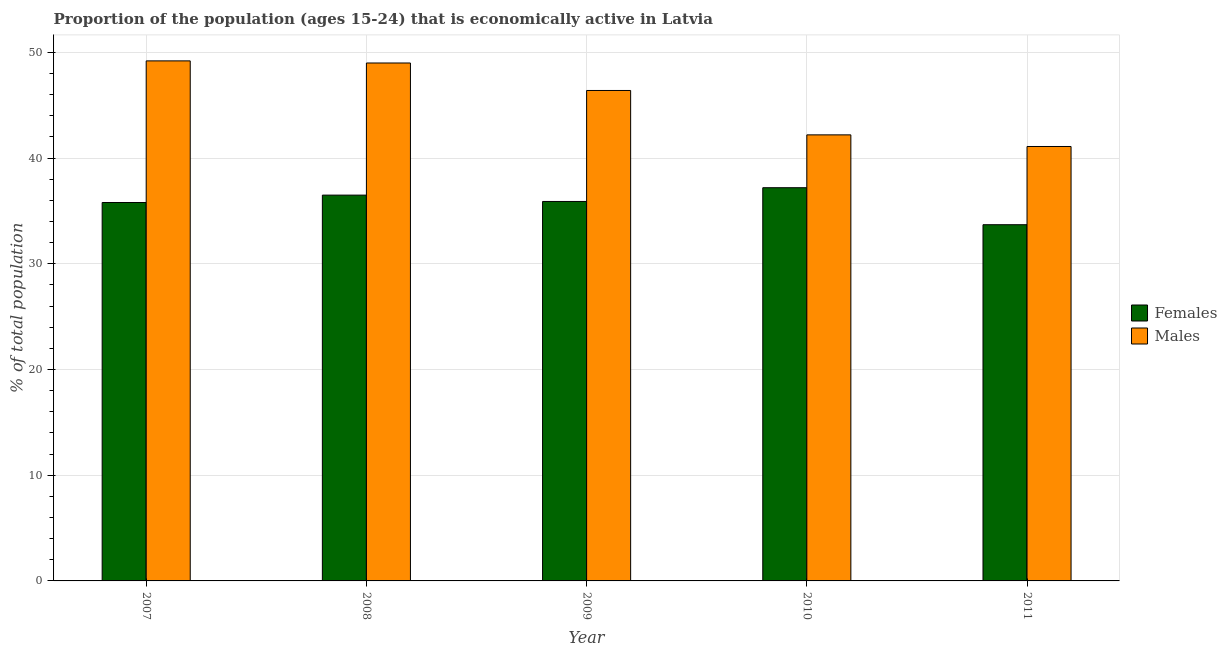How many groups of bars are there?
Keep it short and to the point. 5. Are the number of bars per tick equal to the number of legend labels?
Offer a terse response. Yes. How many bars are there on the 3rd tick from the left?
Your answer should be compact. 2. What is the label of the 3rd group of bars from the left?
Make the answer very short. 2009. What is the percentage of economically active female population in 2011?
Provide a succinct answer. 33.7. Across all years, what is the maximum percentage of economically active male population?
Give a very brief answer. 49.2. Across all years, what is the minimum percentage of economically active female population?
Your answer should be very brief. 33.7. In which year was the percentage of economically active male population maximum?
Your response must be concise. 2007. What is the total percentage of economically active female population in the graph?
Your response must be concise. 179.1. What is the difference between the percentage of economically active male population in 2008 and that in 2009?
Ensure brevity in your answer.  2.6. What is the difference between the percentage of economically active female population in 2008 and the percentage of economically active male population in 2007?
Keep it short and to the point. 0.7. What is the average percentage of economically active male population per year?
Your answer should be compact. 45.58. In how many years, is the percentage of economically active male population greater than 8 %?
Keep it short and to the point. 5. What is the ratio of the percentage of economically active female population in 2007 to that in 2009?
Offer a very short reply. 1. What is the difference between the highest and the second highest percentage of economically active female population?
Your answer should be compact. 0.7. What is the difference between the highest and the lowest percentage of economically active female population?
Keep it short and to the point. 3.5. In how many years, is the percentage of economically active female population greater than the average percentage of economically active female population taken over all years?
Your answer should be compact. 3. What does the 1st bar from the left in 2010 represents?
Offer a very short reply. Females. What does the 2nd bar from the right in 2008 represents?
Keep it short and to the point. Females. Are all the bars in the graph horizontal?
Make the answer very short. No. How many years are there in the graph?
Your answer should be compact. 5. What is the difference between two consecutive major ticks on the Y-axis?
Provide a succinct answer. 10. Does the graph contain any zero values?
Give a very brief answer. No. Does the graph contain grids?
Provide a succinct answer. Yes. How many legend labels are there?
Give a very brief answer. 2. What is the title of the graph?
Your answer should be very brief. Proportion of the population (ages 15-24) that is economically active in Latvia. What is the label or title of the Y-axis?
Offer a terse response. % of total population. What is the % of total population of Females in 2007?
Offer a very short reply. 35.8. What is the % of total population in Males in 2007?
Provide a short and direct response. 49.2. What is the % of total population of Females in 2008?
Offer a very short reply. 36.5. What is the % of total population in Males in 2008?
Your response must be concise. 49. What is the % of total population of Females in 2009?
Your answer should be very brief. 35.9. What is the % of total population in Males in 2009?
Make the answer very short. 46.4. What is the % of total population of Females in 2010?
Your answer should be very brief. 37.2. What is the % of total population in Males in 2010?
Offer a terse response. 42.2. What is the % of total population of Females in 2011?
Make the answer very short. 33.7. What is the % of total population in Males in 2011?
Your response must be concise. 41.1. Across all years, what is the maximum % of total population of Females?
Give a very brief answer. 37.2. Across all years, what is the maximum % of total population of Males?
Provide a short and direct response. 49.2. Across all years, what is the minimum % of total population in Females?
Your response must be concise. 33.7. Across all years, what is the minimum % of total population in Males?
Offer a very short reply. 41.1. What is the total % of total population in Females in the graph?
Keep it short and to the point. 179.1. What is the total % of total population in Males in the graph?
Your answer should be very brief. 227.9. What is the difference between the % of total population of Females in 2007 and that in 2009?
Keep it short and to the point. -0.1. What is the difference between the % of total population of Males in 2007 and that in 2009?
Your response must be concise. 2.8. What is the difference between the % of total population of Females in 2007 and that in 2010?
Your answer should be compact. -1.4. What is the difference between the % of total population in Males in 2007 and that in 2010?
Your answer should be very brief. 7. What is the difference between the % of total population of Females in 2007 and that in 2011?
Offer a terse response. 2.1. What is the difference between the % of total population in Males in 2007 and that in 2011?
Provide a short and direct response. 8.1. What is the difference between the % of total population of Females in 2008 and that in 2009?
Give a very brief answer. 0.6. What is the difference between the % of total population of Males in 2008 and that in 2009?
Your response must be concise. 2.6. What is the difference between the % of total population in Females in 2008 and that in 2010?
Your answer should be compact. -0.7. What is the difference between the % of total population of Males in 2009 and that in 2010?
Offer a terse response. 4.2. What is the difference between the % of total population in Females in 2009 and that in 2011?
Ensure brevity in your answer.  2.2. What is the difference between the % of total population in Males in 2009 and that in 2011?
Make the answer very short. 5.3. What is the difference between the % of total population of Females in 2007 and the % of total population of Males in 2010?
Ensure brevity in your answer.  -6.4. What is the difference between the % of total population in Females in 2007 and the % of total population in Males in 2011?
Offer a terse response. -5.3. What is the difference between the % of total population in Females in 2008 and the % of total population in Males in 2009?
Ensure brevity in your answer.  -9.9. What is the difference between the % of total population in Females in 2008 and the % of total population in Males in 2011?
Provide a short and direct response. -4.6. What is the difference between the % of total population in Females in 2009 and the % of total population in Males in 2010?
Offer a very short reply. -6.3. What is the difference between the % of total population of Females in 2010 and the % of total population of Males in 2011?
Your response must be concise. -3.9. What is the average % of total population of Females per year?
Your answer should be compact. 35.82. What is the average % of total population of Males per year?
Provide a succinct answer. 45.58. In the year 2007, what is the difference between the % of total population in Females and % of total population in Males?
Your response must be concise. -13.4. In the year 2008, what is the difference between the % of total population in Females and % of total population in Males?
Keep it short and to the point. -12.5. What is the ratio of the % of total population of Females in 2007 to that in 2008?
Your answer should be compact. 0.98. What is the ratio of the % of total population of Males in 2007 to that in 2008?
Keep it short and to the point. 1. What is the ratio of the % of total population in Females in 2007 to that in 2009?
Give a very brief answer. 1. What is the ratio of the % of total population of Males in 2007 to that in 2009?
Your response must be concise. 1.06. What is the ratio of the % of total population in Females in 2007 to that in 2010?
Make the answer very short. 0.96. What is the ratio of the % of total population in Males in 2007 to that in 2010?
Make the answer very short. 1.17. What is the ratio of the % of total population of Females in 2007 to that in 2011?
Offer a terse response. 1.06. What is the ratio of the % of total population of Males in 2007 to that in 2011?
Ensure brevity in your answer.  1.2. What is the ratio of the % of total population in Females in 2008 to that in 2009?
Your answer should be compact. 1.02. What is the ratio of the % of total population of Males in 2008 to that in 2009?
Give a very brief answer. 1.06. What is the ratio of the % of total population of Females in 2008 to that in 2010?
Offer a terse response. 0.98. What is the ratio of the % of total population in Males in 2008 to that in 2010?
Make the answer very short. 1.16. What is the ratio of the % of total population of Females in 2008 to that in 2011?
Your answer should be very brief. 1.08. What is the ratio of the % of total population in Males in 2008 to that in 2011?
Provide a succinct answer. 1.19. What is the ratio of the % of total population of Females in 2009 to that in 2010?
Keep it short and to the point. 0.97. What is the ratio of the % of total population of Males in 2009 to that in 2010?
Ensure brevity in your answer.  1.1. What is the ratio of the % of total population of Females in 2009 to that in 2011?
Ensure brevity in your answer.  1.07. What is the ratio of the % of total population of Males in 2009 to that in 2011?
Offer a terse response. 1.13. What is the ratio of the % of total population of Females in 2010 to that in 2011?
Make the answer very short. 1.1. What is the ratio of the % of total population of Males in 2010 to that in 2011?
Your response must be concise. 1.03. What is the difference between the highest and the second highest % of total population in Females?
Ensure brevity in your answer.  0.7. 